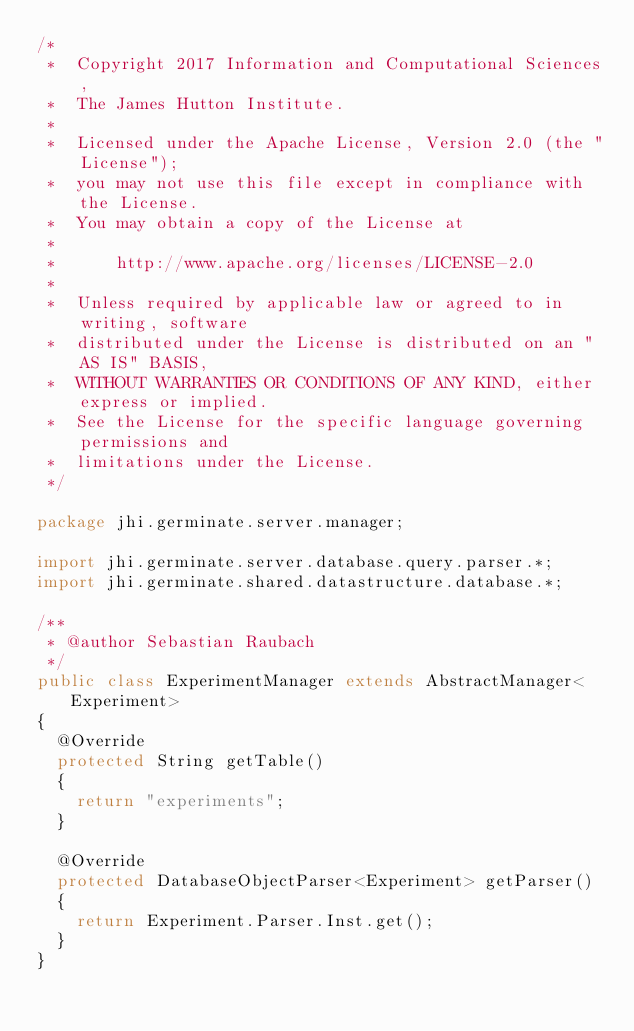Convert code to text. <code><loc_0><loc_0><loc_500><loc_500><_Java_>/*
 *  Copyright 2017 Information and Computational Sciences,
 *  The James Hutton Institute.
 *
 *  Licensed under the Apache License, Version 2.0 (the "License");
 *  you may not use this file except in compliance with the License.
 *  You may obtain a copy of the License at
 *
 *      http://www.apache.org/licenses/LICENSE-2.0
 *
 *  Unless required by applicable law or agreed to in writing, software
 *  distributed under the License is distributed on an "AS IS" BASIS,
 *  WITHOUT WARRANTIES OR CONDITIONS OF ANY KIND, either express or implied.
 *  See the License for the specific language governing permissions and
 *  limitations under the License.
 */

package jhi.germinate.server.manager;

import jhi.germinate.server.database.query.parser.*;
import jhi.germinate.shared.datastructure.database.*;

/**
 * @author Sebastian Raubach
 */
public class ExperimentManager extends AbstractManager<Experiment>
{
	@Override
	protected String getTable()
	{
		return "experiments";
	}

	@Override
	protected DatabaseObjectParser<Experiment> getParser()
	{
		return Experiment.Parser.Inst.get();
	}
}
</code> 